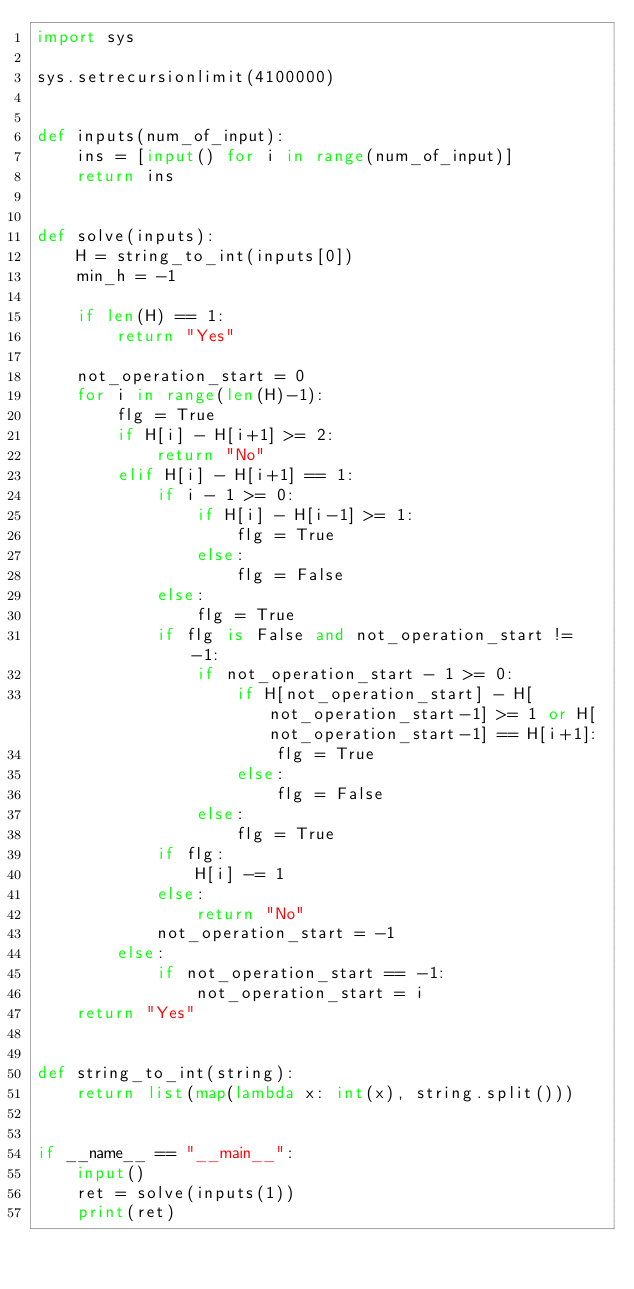Convert code to text. <code><loc_0><loc_0><loc_500><loc_500><_Python_>import sys

sys.setrecursionlimit(4100000)


def inputs(num_of_input):
    ins = [input() for i in range(num_of_input)]
    return ins


def solve(inputs):
    H = string_to_int(inputs[0])
    min_h = -1

    if len(H) == 1:
        return "Yes"

    not_operation_start = 0
    for i in range(len(H)-1):
        flg = True
        if H[i] - H[i+1] >= 2:
            return "No"
        elif H[i] - H[i+1] == 1:
            if i - 1 >= 0:
                if H[i] - H[i-1] >= 1:
                    flg = True
                else:
                    flg = False
            else:
                flg = True
            if flg is False and not_operation_start != -1:
                if not_operation_start - 1 >= 0:
                    if H[not_operation_start] - H[not_operation_start-1] >= 1 or H[not_operation_start-1] == H[i+1]:
                        flg = True
                    else:
                        flg = False
                else:
                    flg = True
            if flg:
                H[i] -= 1
            else:
                return "No"
            not_operation_start = -1
        else:
            if not_operation_start == -1:
                not_operation_start = i
    return "Yes"


def string_to_int(string):
    return list(map(lambda x: int(x), string.split()))


if __name__ == "__main__":
    input()
    ret = solve(inputs(1))
    print(ret)
</code> 